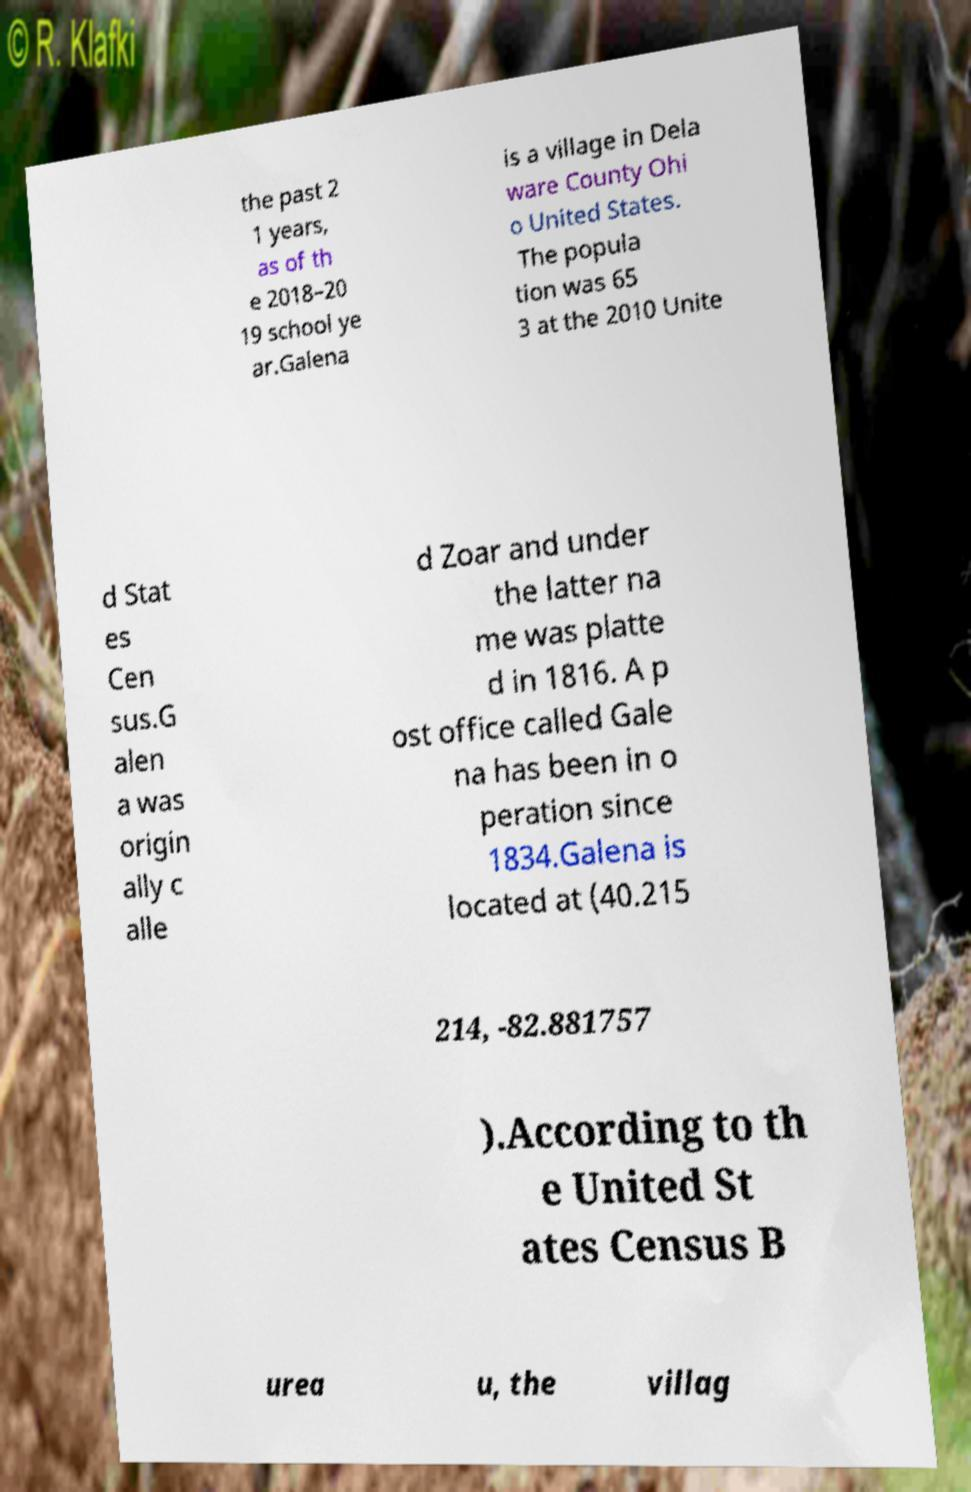For documentation purposes, I need the text within this image transcribed. Could you provide that? the past 2 1 years, as of th e 2018–20 19 school ye ar.Galena is a village in Dela ware County Ohi o United States. The popula tion was 65 3 at the 2010 Unite d Stat es Cen sus.G alen a was origin ally c alle d Zoar and under the latter na me was platte d in 1816. A p ost office called Gale na has been in o peration since 1834.Galena is located at (40.215 214, -82.881757 ).According to th e United St ates Census B urea u, the villag 